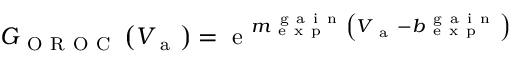<formula> <loc_0><loc_0><loc_500><loc_500>\begin{array} { r } { G _ { O R O C } \left ( V _ { a } \right ) = e ^ { m _ { e x p } ^ { g a i n } \left ( V _ { a } - b _ { e x p } ^ { g a i n } \right ) } } \end{array}</formula> 